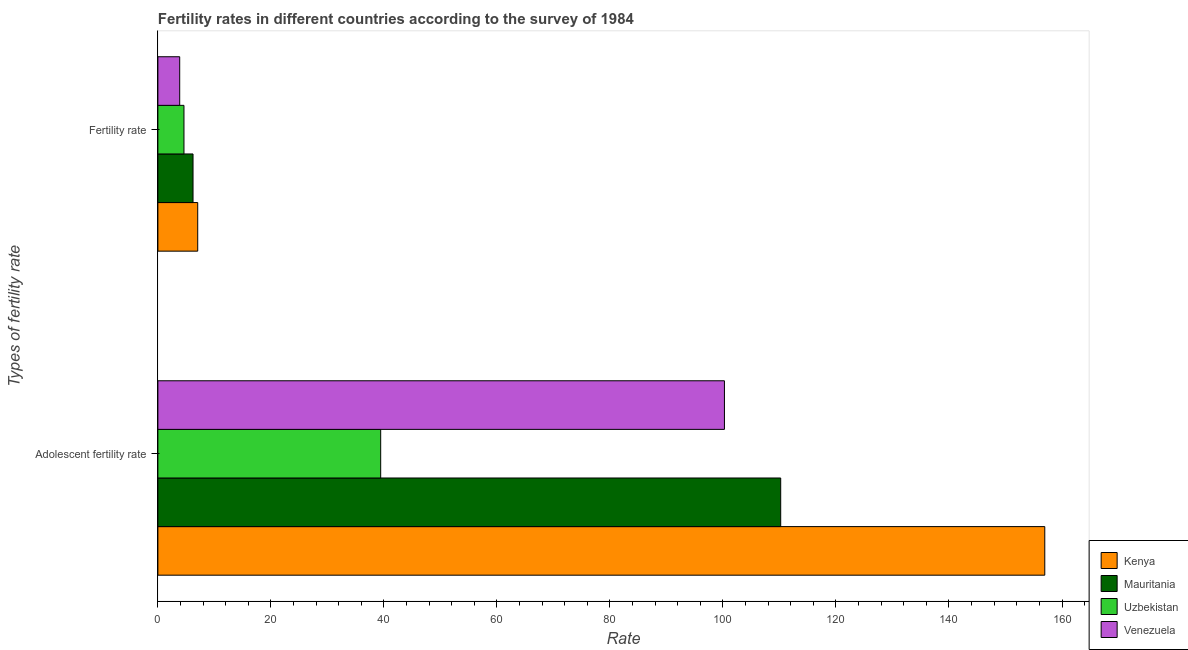How many different coloured bars are there?
Make the answer very short. 4. How many groups of bars are there?
Keep it short and to the point. 2. What is the label of the 1st group of bars from the top?
Keep it short and to the point. Fertility rate. What is the fertility rate in Uzbekistan?
Make the answer very short. 4.62. Across all countries, what is the maximum fertility rate?
Keep it short and to the point. 7.05. Across all countries, what is the minimum fertility rate?
Provide a succinct answer. 3.86. In which country was the adolescent fertility rate maximum?
Your answer should be very brief. Kenya. In which country was the fertility rate minimum?
Keep it short and to the point. Venezuela. What is the total adolescent fertility rate in the graph?
Provide a succinct answer. 406.86. What is the difference between the fertility rate in Venezuela and that in Mauritania?
Give a very brief answer. -2.36. What is the difference between the fertility rate in Uzbekistan and the adolescent fertility rate in Venezuela?
Your answer should be very brief. -95.65. What is the average fertility rate per country?
Offer a terse response. 5.44. What is the difference between the fertility rate and adolescent fertility rate in Venezuela?
Offer a very short reply. -96.4. In how many countries, is the adolescent fertility rate greater than 64 ?
Ensure brevity in your answer.  3. What is the ratio of the adolescent fertility rate in Venezuela to that in Kenya?
Offer a very short reply. 0.64. Is the fertility rate in Uzbekistan less than that in Kenya?
Make the answer very short. Yes. What does the 1st bar from the top in Adolescent fertility rate represents?
Provide a succinct answer. Venezuela. What does the 4th bar from the bottom in Adolescent fertility rate represents?
Your answer should be very brief. Venezuela. How many bars are there?
Offer a very short reply. 8. How many countries are there in the graph?
Provide a succinct answer. 4. Does the graph contain grids?
Your answer should be very brief. No. Where does the legend appear in the graph?
Offer a very short reply. Bottom right. How many legend labels are there?
Offer a very short reply. 4. How are the legend labels stacked?
Your response must be concise. Vertical. What is the title of the graph?
Provide a short and direct response. Fertility rates in different countries according to the survey of 1984. Does "Bhutan" appear as one of the legend labels in the graph?
Keep it short and to the point. No. What is the label or title of the X-axis?
Provide a short and direct response. Rate. What is the label or title of the Y-axis?
Give a very brief answer. Types of fertility rate. What is the Rate of Kenya in Adolescent fertility rate?
Make the answer very short. 156.95. What is the Rate of Mauritania in Adolescent fertility rate?
Make the answer very short. 110.22. What is the Rate of Uzbekistan in Adolescent fertility rate?
Offer a very short reply. 39.43. What is the Rate in Venezuela in Adolescent fertility rate?
Offer a very short reply. 100.26. What is the Rate of Kenya in Fertility rate?
Offer a terse response. 7.05. What is the Rate of Mauritania in Fertility rate?
Your response must be concise. 6.22. What is the Rate of Uzbekistan in Fertility rate?
Offer a very short reply. 4.62. What is the Rate of Venezuela in Fertility rate?
Offer a very short reply. 3.86. Across all Types of fertility rate, what is the maximum Rate in Kenya?
Offer a very short reply. 156.95. Across all Types of fertility rate, what is the maximum Rate of Mauritania?
Provide a short and direct response. 110.22. Across all Types of fertility rate, what is the maximum Rate in Uzbekistan?
Keep it short and to the point. 39.43. Across all Types of fertility rate, what is the maximum Rate of Venezuela?
Your response must be concise. 100.26. Across all Types of fertility rate, what is the minimum Rate of Kenya?
Give a very brief answer. 7.05. Across all Types of fertility rate, what is the minimum Rate in Mauritania?
Give a very brief answer. 6.22. Across all Types of fertility rate, what is the minimum Rate of Uzbekistan?
Keep it short and to the point. 4.62. Across all Types of fertility rate, what is the minimum Rate in Venezuela?
Ensure brevity in your answer.  3.86. What is the total Rate of Kenya in the graph?
Provide a short and direct response. 164. What is the total Rate in Mauritania in the graph?
Your answer should be compact. 116.44. What is the total Rate of Uzbekistan in the graph?
Give a very brief answer. 44.04. What is the total Rate of Venezuela in the graph?
Keep it short and to the point. 104.12. What is the difference between the Rate in Kenya in Adolescent fertility rate and that in Fertility rate?
Keep it short and to the point. 149.9. What is the difference between the Rate in Mauritania in Adolescent fertility rate and that in Fertility rate?
Offer a terse response. 104. What is the difference between the Rate of Uzbekistan in Adolescent fertility rate and that in Fertility rate?
Ensure brevity in your answer.  34.81. What is the difference between the Rate in Venezuela in Adolescent fertility rate and that in Fertility rate?
Give a very brief answer. 96.4. What is the difference between the Rate in Kenya in Adolescent fertility rate and the Rate in Mauritania in Fertility rate?
Your answer should be very brief. 150.73. What is the difference between the Rate in Kenya in Adolescent fertility rate and the Rate in Uzbekistan in Fertility rate?
Offer a very short reply. 152.34. What is the difference between the Rate in Kenya in Adolescent fertility rate and the Rate in Venezuela in Fertility rate?
Keep it short and to the point. 153.09. What is the difference between the Rate of Mauritania in Adolescent fertility rate and the Rate of Uzbekistan in Fertility rate?
Your answer should be compact. 105.6. What is the difference between the Rate of Mauritania in Adolescent fertility rate and the Rate of Venezuela in Fertility rate?
Make the answer very short. 106.36. What is the difference between the Rate of Uzbekistan in Adolescent fertility rate and the Rate of Venezuela in Fertility rate?
Keep it short and to the point. 35.57. What is the average Rate of Kenya per Types of fertility rate?
Your answer should be very brief. 82. What is the average Rate in Mauritania per Types of fertility rate?
Your answer should be compact. 58.22. What is the average Rate in Uzbekistan per Types of fertility rate?
Your answer should be very brief. 22.02. What is the average Rate in Venezuela per Types of fertility rate?
Provide a short and direct response. 52.06. What is the difference between the Rate in Kenya and Rate in Mauritania in Adolescent fertility rate?
Offer a terse response. 46.74. What is the difference between the Rate in Kenya and Rate in Uzbekistan in Adolescent fertility rate?
Provide a short and direct response. 117.53. What is the difference between the Rate of Kenya and Rate of Venezuela in Adolescent fertility rate?
Make the answer very short. 56.69. What is the difference between the Rate in Mauritania and Rate in Uzbekistan in Adolescent fertility rate?
Keep it short and to the point. 70.79. What is the difference between the Rate of Mauritania and Rate of Venezuela in Adolescent fertility rate?
Provide a succinct answer. 9.95. What is the difference between the Rate in Uzbekistan and Rate in Venezuela in Adolescent fertility rate?
Ensure brevity in your answer.  -60.84. What is the difference between the Rate of Kenya and Rate of Mauritania in Fertility rate?
Your response must be concise. 0.83. What is the difference between the Rate of Kenya and Rate of Uzbekistan in Fertility rate?
Make the answer very short. 2.43. What is the difference between the Rate of Kenya and Rate of Venezuela in Fertility rate?
Offer a terse response. 3.19. What is the difference between the Rate in Mauritania and Rate in Uzbekistan in Fertility rate?
Ensure brevity in your answer.  1.6. What is the difference between the Rate in Mauritania and Rate in Venezuela in Fertility rate?
Your answer should be compact. 2.36. What is the difference between the Rate of Uzbekistan and Rate of Venezuela in Fertility rate?
Offer a terse response. 0.76. What is the ratio of the Rate of Kenya in Adolescent fertility rate to that in Fertility rate?
Provide a succinct answer. 22.27. What is the ratio of the Rate of Mauritania in Adolescent fertility rate to that in Fertility rate?
Your response must be concise. 17.72. What is the ratio of the Rate in Uzbekistan in Adolescent fertility rate to that in Fertility rate?
Offer a very short reply. 8.54. What is the ratio of the Rate of Venezuela in Adolescent fertility rate to that in Fertility rate?
Ensure brevity in your answer.  25.97. What is the difference between the highest and the second highest Rate of Kenya?
Give a very brief answer. 149.9. What is the difference between the highest and the second highest Rate in Mauritania?
Your answer should be compact. 104. What is the difference between the highest and the second highest Rate in Uzbekistan?
Give a very brief answer. 34.81. What is the difference between the highest and the second highest Rate in Venezuela?
Provide a succinct answer. 96.4. What is the difference between the highest and the lowest Rate of Kenya?
Make the answer very short. 149.9. What is the difference between the highest and the lowest Rate of Mauritania?
Provide a short and direct response. 104. What is the difference between the highest and the lowest Rate of Uzbekistan?
Keep it short and to the point. 34.81. What is the difference between the highest and the lowest Rate of Venezuela?
Your answer should be very brief. 96.4. 